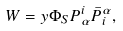<formula> <loc_0><loc_0><loc_500><loc_500>W = y \Phi _ { S } P ^ { i } _ { \alpha } \bar { P } _ { i } ^ { \alpha } ,</formula> 